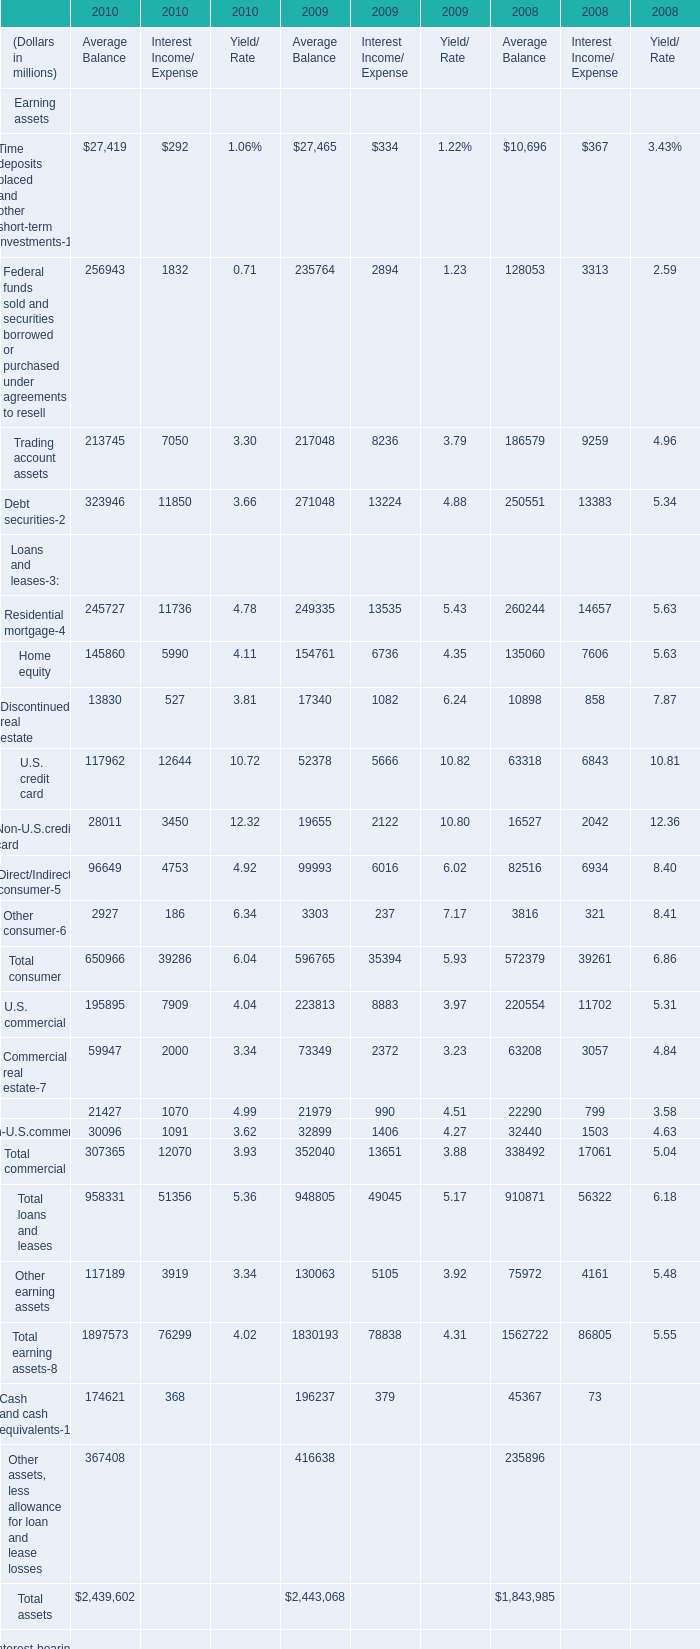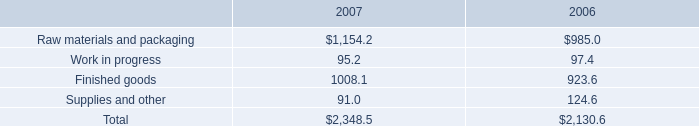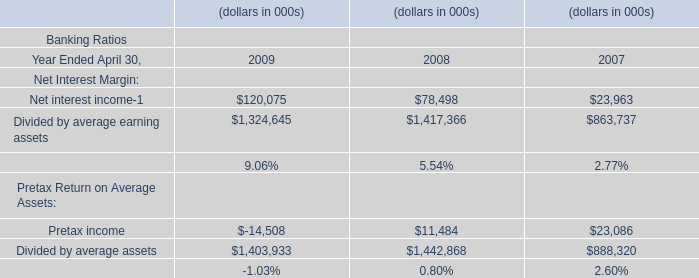In the year with largest amount of home equity in Average Balance in table 0, what's the increasing rate of Trading account assets in Average Balance in table 0? 
Computations: ((217048 - 186579) / 186579)
Answer: 0.1633. 